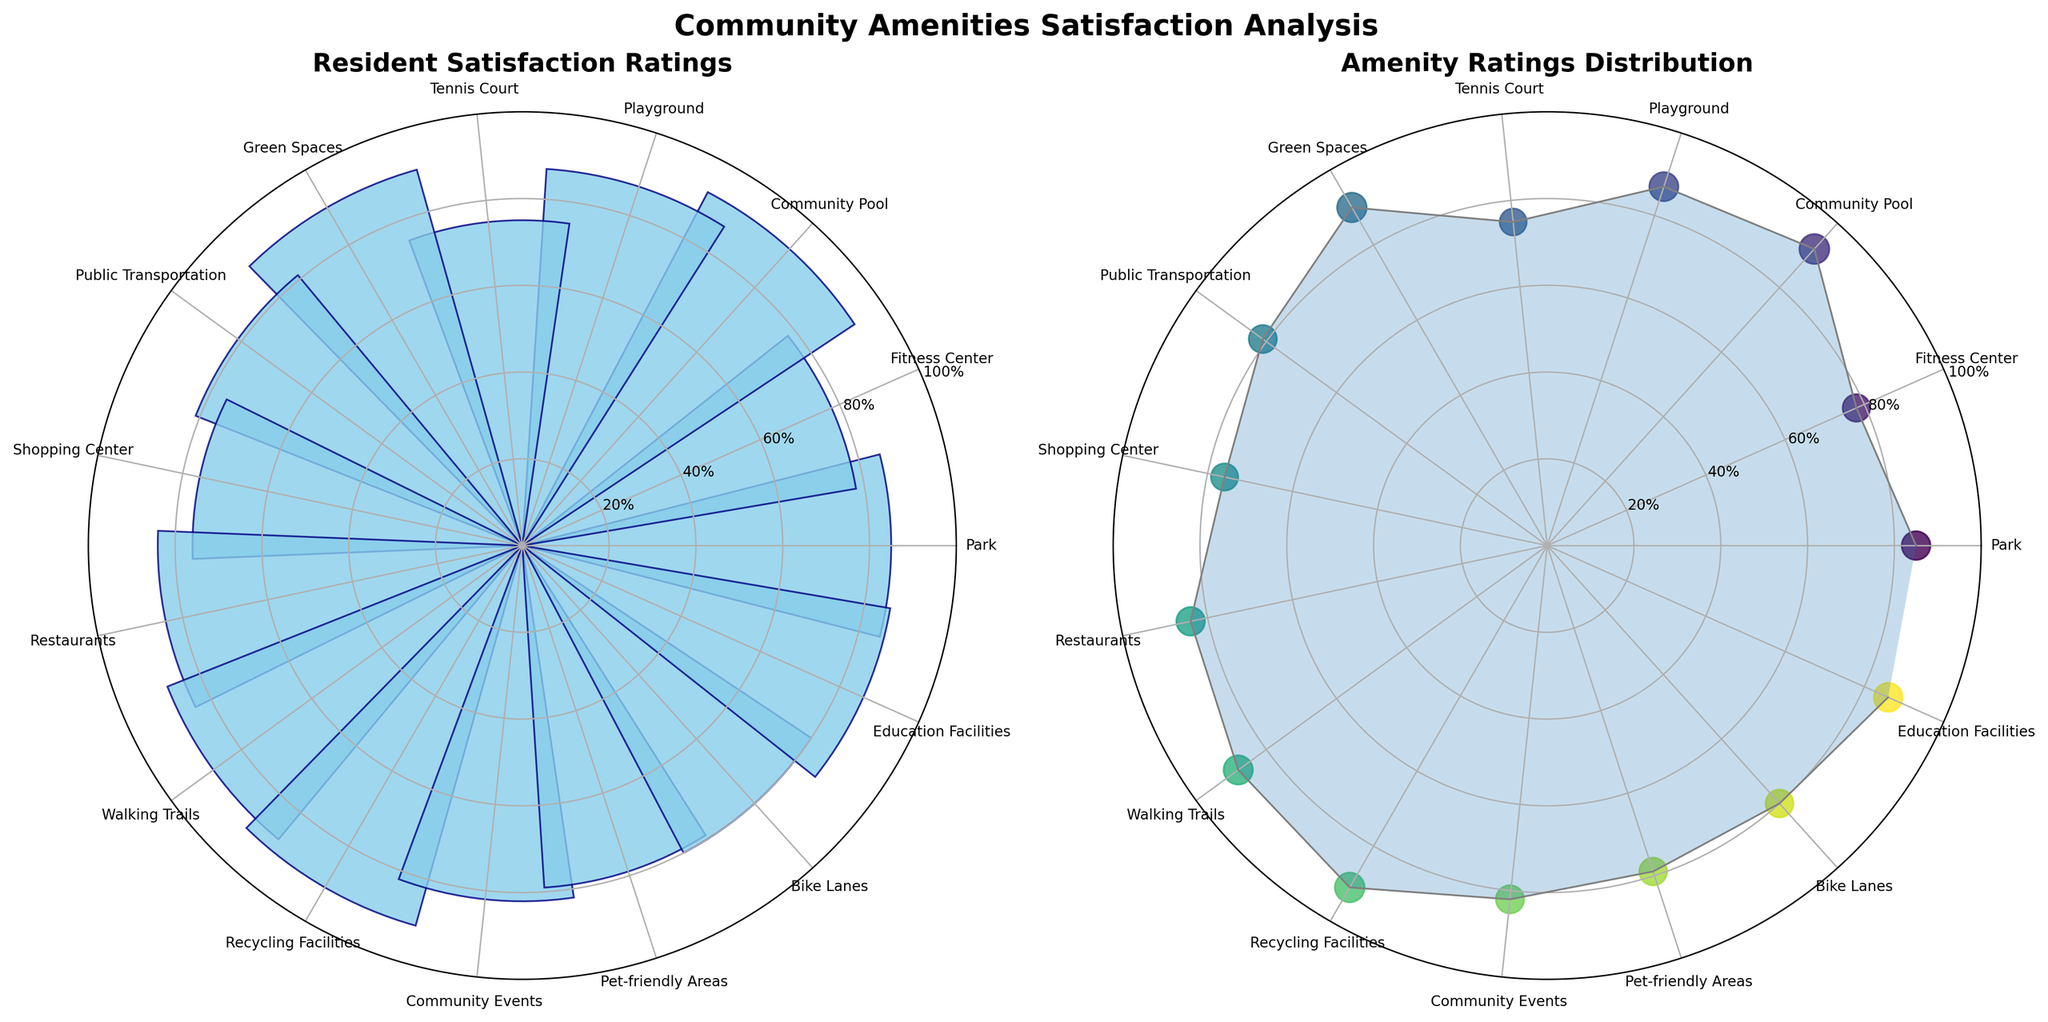What is the title of the first subplot? The title of the subplot is located at the top of the subplot. For the first subplot, it reads "Resident Satisfaction Ratings"
Answer: Resident Satisfaction Ratings How many amenities have their satisfaction ratings plotted? The number of data points equal to the number of amenities is provided in the data. By counting the amenities listed in the plot, there are 15 in total.
Answer: 15 Which amenity has the highest satisfaction rating? By examining the highest bar in the first subplot or the highest point in the second subplot, the "Community Pool" has the highest value.
Answer: Community Pool What are the satisfaction ratings for Tennis Court and Public Transportation? Look at the positions corresponding to "Tennis Court" and "Public Transportation" on the plot and read their respective ratings. "Tennis Court" is at 75, and "Public Transportation" is at 81.
Answer: 75 and 81 What is the average satisfaction rating across all amenities? Add all the satisfaction ratings together and divide by the number of amenities: (85 + 78 + 92 + 87 + 75 + 90 + 81 + 76 + 84 + 88 + 91 + 82 + 79 + 80 + 86) / 15 = 83.133...
Answer: 83.1 Which amenities have satisfaction ratings above 85? Check each bar in the first subplot or each point in the second subplot. The amenities with ratings above 85% are: Park, Community Pool, Playground, Green Spaces, Walking Trails, Recycling Facilities, Education Facilities.
Answer: Park, Community Pool, Playground, Green Spaces, Walking Trails, Recycling Facilities, Education Facilities What is the satisfaction rating difference between the highest-rated and lowest-rated amenities? Subtract the lowest rating from the highest rating: 92 (Community Pool) - 75 (Tennis Court) = 17.
Answer: 17 Which subplot uses colored scatter plots to represent ratings? The second subplot uses colored scatter plots and lines connecting the points to represent ratings visually.
Answer: Second subplot What is the median satisfaction rating for all amenities? Order the ratings and find the middle value(s). The ordered ratings are: {75, 76, 78, 79, 80, 81, 82, 84, 85, 86, 87, 88, 90, 91, 92}. The middle values are 84.
Answer: 84 Are there any amenities with the same satisfaction rating? Examine the plot for any bars or points that align exactly. There are no amenities with matching ratings in the given list; hence, all have unique ratings.
Answer: No 